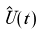<formula> <loc_0><loc_0><loc_500><loc_500>\hat { U } ( t )</formula> 